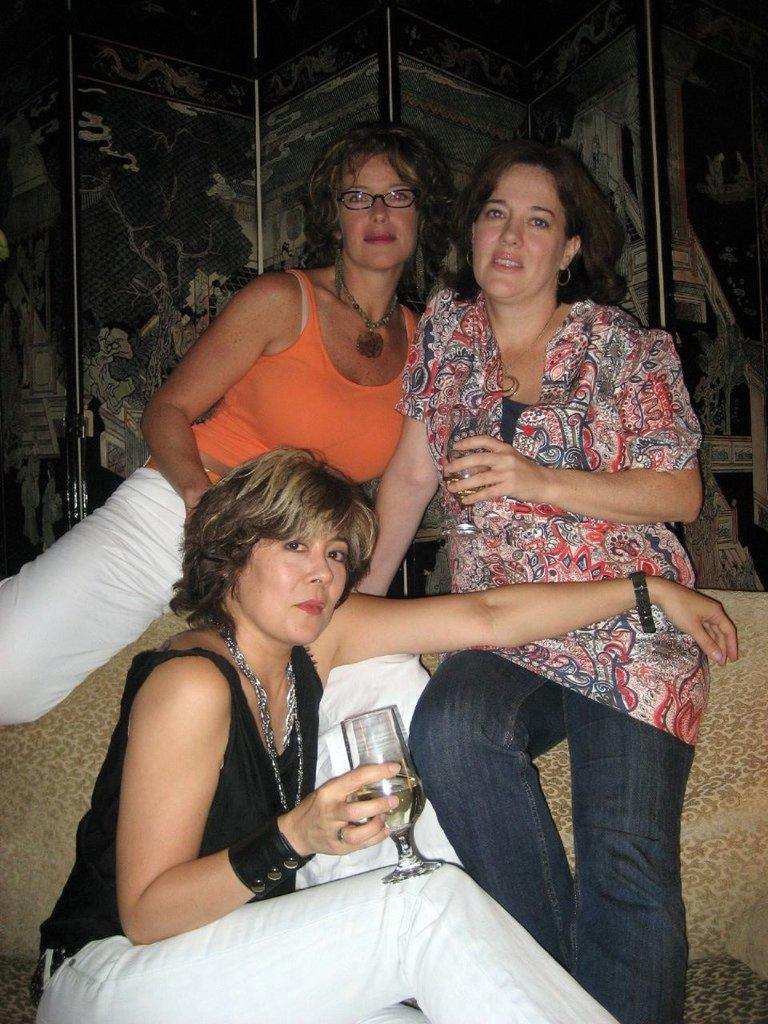Who or what can be seen in the image? There are people in the image. What are two of the people holding? Two people are holding glasses. What type of furniture is present in the image? There is a sofa in the image. What can be seen in the background of the image? There is a wall with architecture in the background of the image. What type of coast is visible in the image? There is no coast visible in the image; it features people, glasses, a sofa, and a wall with architecture. Who is the representative of the group in the image? The image does not depict a group or any representative; it simply shows people, glasses, a sofa, and a wall with architecture. 